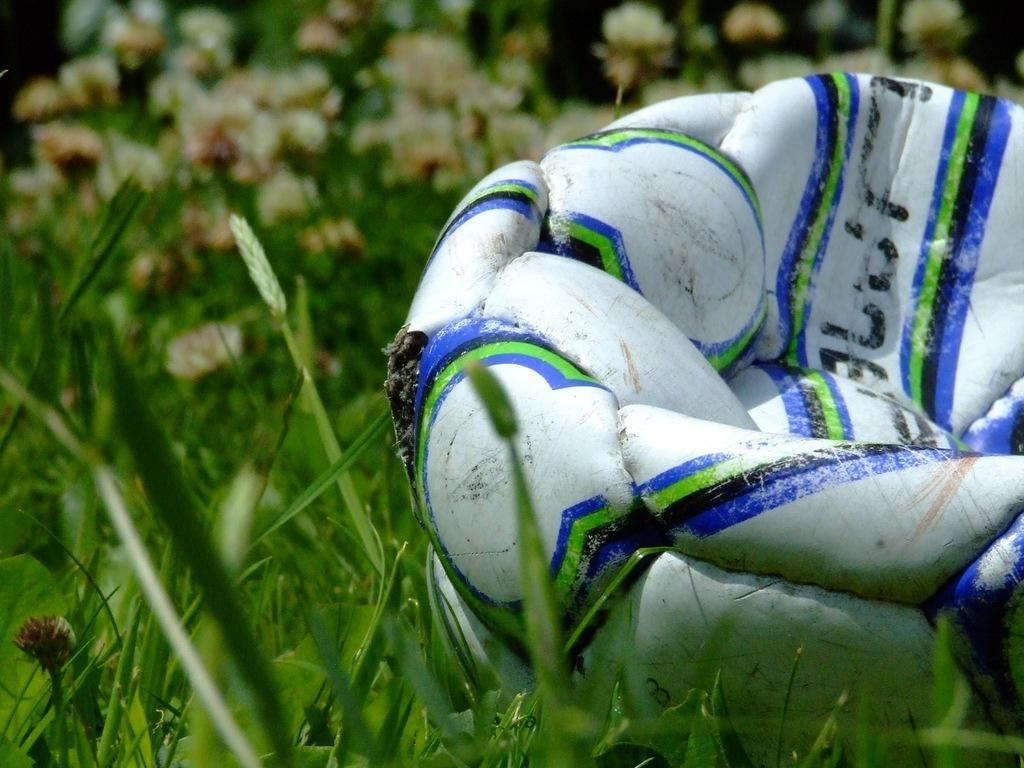Please provide a concise description of this image. There is a football on the right side of this image. We can see a grass and plants in the background. 